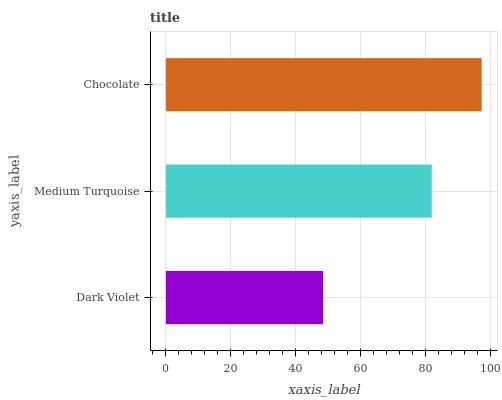Is Dark Violet the minimum?
Answer yes or no. Yes. Is Chocolate the maximum?
Answer yes or no. Yes. Is Medium Turquoise the minimum?
Answer yes or no. No. Is Medium Turquoise the maximum?
Answer yes or no. No. Is Medium Turquoise greater than Dark Violet?
Answer yes or no. Yes. Is Dark Violet less than Medium Turquoise?
Answer yes or no. Yes. Is Dark Violet greater than Medium Turquoise?
Answer yes or no. No. Is Medium Turquoise less than Dark Violet?
Answer yes or no. No. Is Medium Turquoise the high median?
Answer yes or no. Yes. Is Medium Turquoise the low median?
Answer yes or no. Yes. Is Chocolate the high median?
Answer yes or no. No. Is Chocolate the low median?
Answer yes or no. No. 